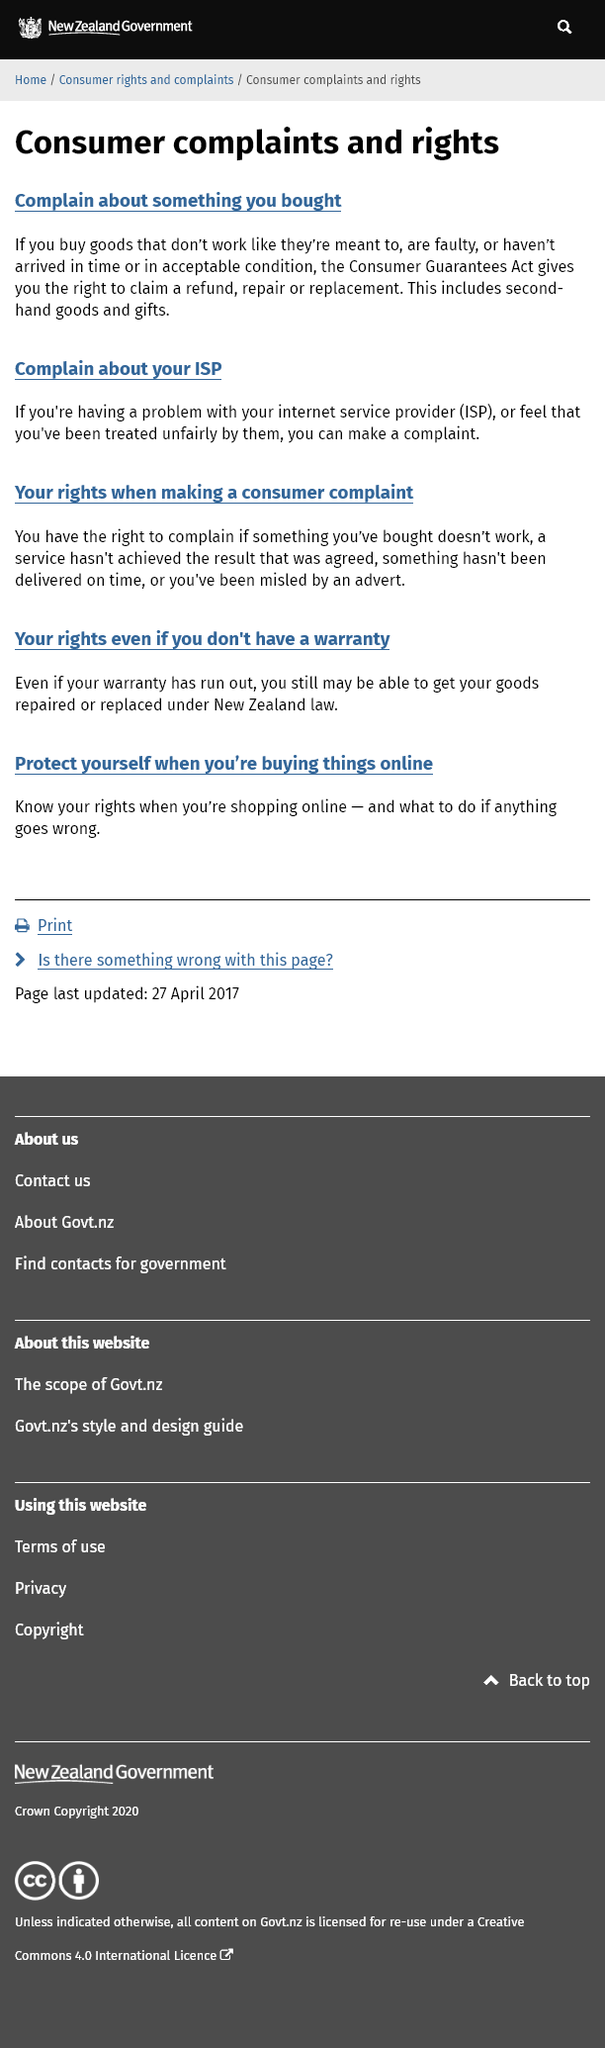Highlight a few significant elements in this photo. You have the right to complain to your ISP if you are experiencing issues or feel that you have been treated unfairly. I have the right to make a consumer complaint when I have purchased something that does not work as intended, received a service that did not meet the agreed-upon result, not received a delivery on time, or have been misled by a misleading advertisement. The Consumer Guarantees Act provides consumers with the right to claim a refund, repair, or replacement for goods that are faulty, do not function as intended, or have not been delivered in a timely and acceptable condition. 